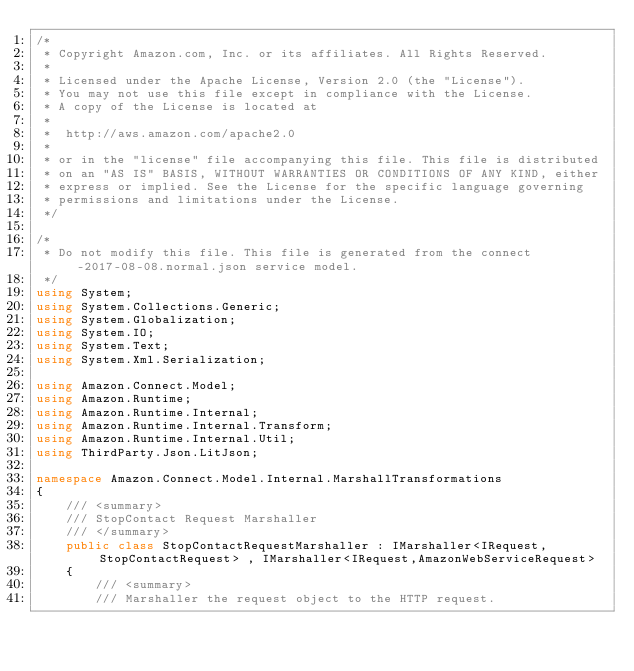<code> <loc_0><loc_0><loc_500><loc_500><_C#_>/*
 * Copyright Amazon.com, Inc. or its affiliates. All Rights Reserved.
 * 
 * Licensed under the Apache License, Version 2.0 (the "License").
 * You may not use this file except in compliance with the License.
 * A copy of the License is located at
 * 
 *  http://aws.amazon.com/apache2.0
 * 
 * or in the "license" file accompanying this file. This file is distributed
 * on an "AS IS" BASIS, WITHOUT WARRANTIES OR CONDITIONS OF ANY KIND, either
 * express or implied. See the License for the specific language governing
 * permissions and limitations under the License.
 */

/*
 * Do not modify this file. This file is generated from the connect-2017-08-08.normal.json service model.
 */
using System;
using System.Collections.Generic;
using System.Globalization;
using System.IO;
using System.Text;
using System.Xml.Serialization;

using Amazon.Connect.Model;
using Amazon.Runtime;
using Amazon.Runtime.Internal;
using Amazon.Runtime.Internal.Transform;
using Amazon.Runtime.Internal.Util;
using ThirdParty.Json.LitJson;

namespace Amazon.Connect.Model.Internal.MarshallTransformations
{
    /// <summary>
    /// StopContact Request Marshaller
    /// </summary>       
    public class StopContactRequestMarshaller : IMarshaller<IRequest, StopContactRequest> , IMarshaller<IRequest,AmazonWebServiceRequest>
    {
        /// <summary>
        /// Marshaller the request object to the HTTP request.</code> 